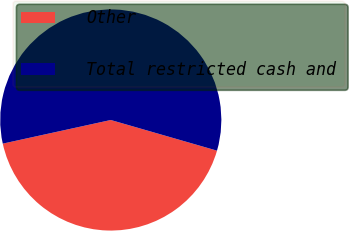Convert chart to OTSL. <chart><loc_0><loc_0><loc_500><loc_500><pie_chart><fcel>Other<fcel>Total restricted cash and<nl><fcel>42.1%<fcel>57.9%<nl></chart> 